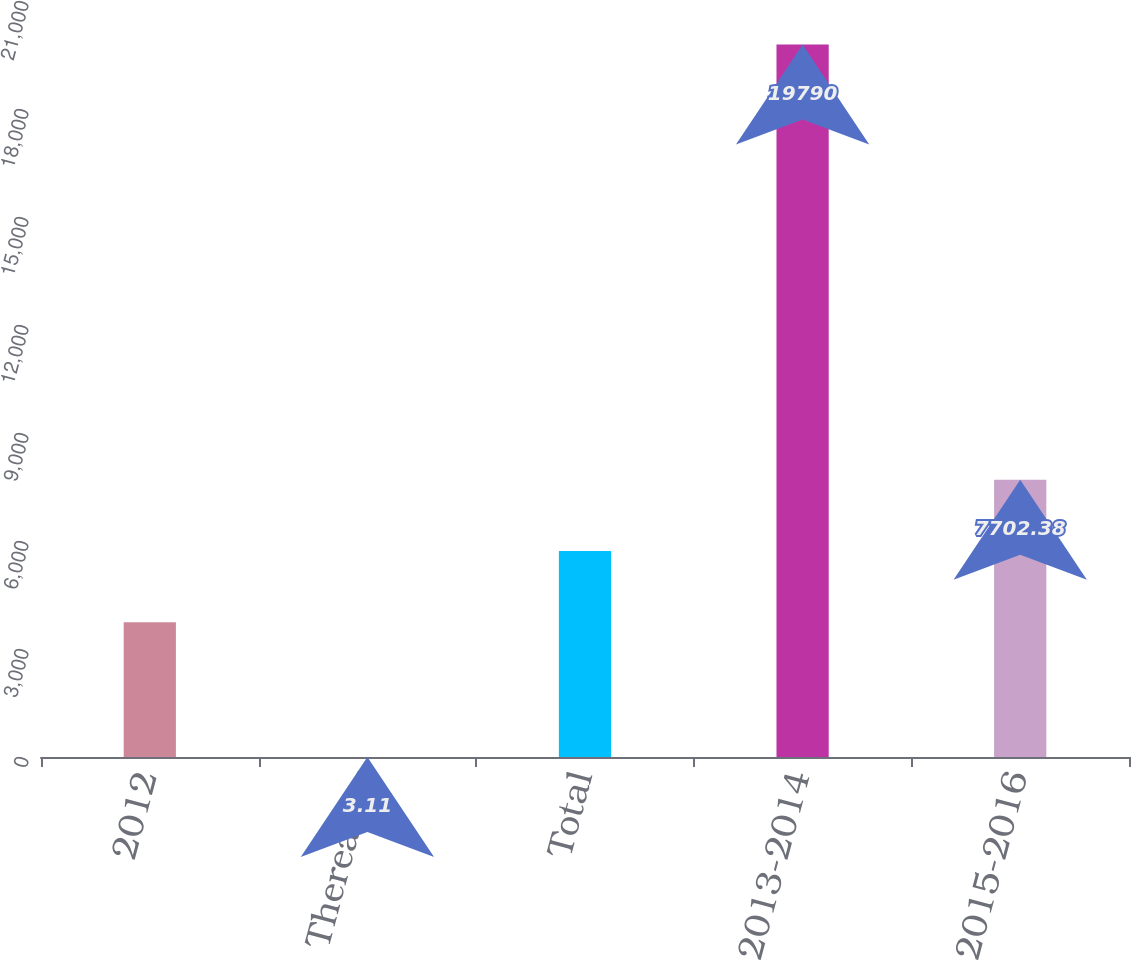Convert chart to OTSL. <chart><loc_0><loc_0><loc_500><loc_500><bar_chart><fcel>2012<fcel>Thereafter<fcel>Total<fcel>2013-2014<fcel>2015-2016<nl><fcel>3745<fcel>3.11<fcel>5723.69<fcel>19790<fcel>7702.38<nl></chart> 